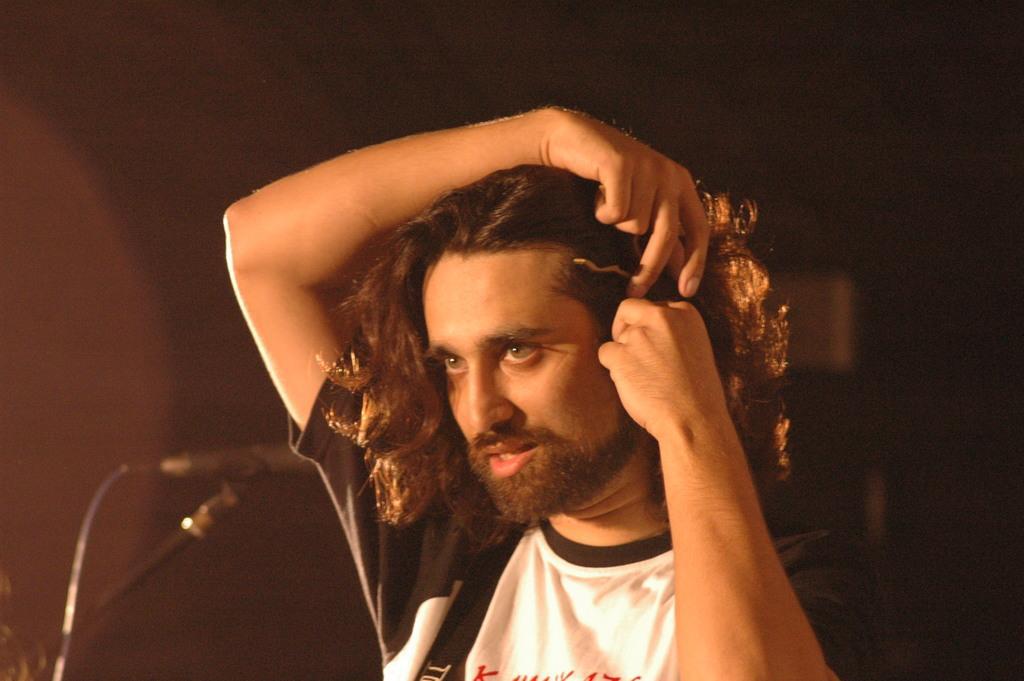Could you give a brief overview of what you see in this image? Here in this picture we can see a man present over a place and he is adjusting his hair and beside him we can see a microphone present. 